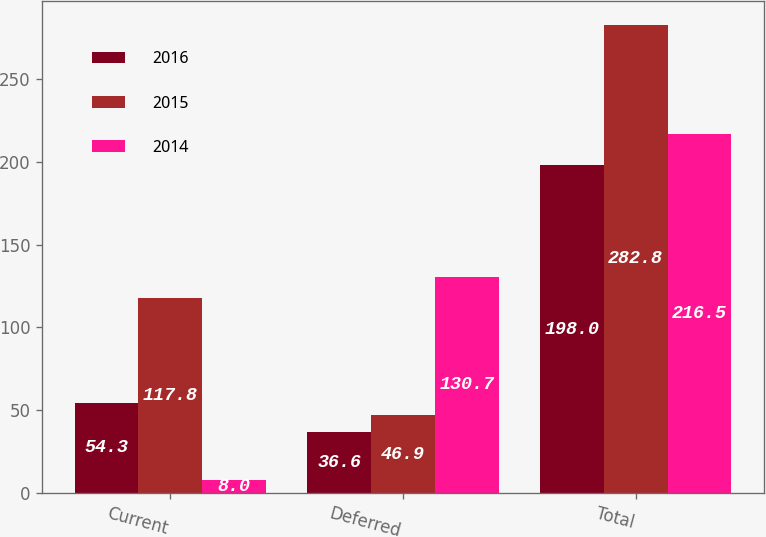<chart> <loc_0><loc_0><loc_500><loc_500><stacked_bar_chart><ecel><fcel>Current<fcel>Deferred<fcel>Total<nl><fcel>2016<fcel>54.3<fcel>36.6<fcel>198<nl><fcel>2015<fcel>117.8<fcel>46.9<fcel>282.8<nl><fcel>2014<fcel>8<fcel>130.7<fcel>216.5<nl></chart> 